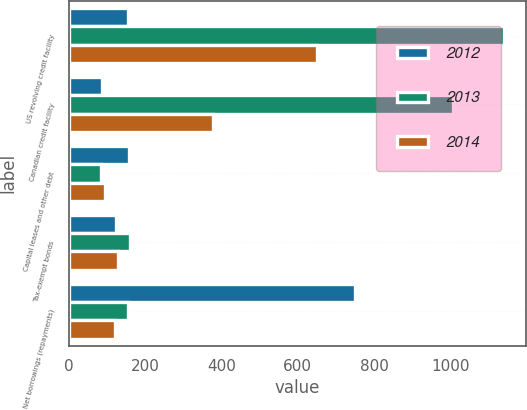Convert chart to OTSL. <chart><loc_0><loc_0><loc_500><loc_500><stacked_bar_chart><ecel><fcel>US revolving credit facility<fcel>Canadian credit facility<fcel>Capital leases and other debt<fcel>Tax-exempt bonds<fcel>Net borrowings (repayments)<nl><fcel>2012<fcel>156<fcel>88<fcel>157<fcel>123<fcel>751<nl><fcel>2013<fcel>1140<fcel>1007<fcel>85<fcel>162<fcel>155<nl><fcel>2014<fcel>650<fcel>379<fcel>96<fcel>129<fcel>122<nl></chart> 